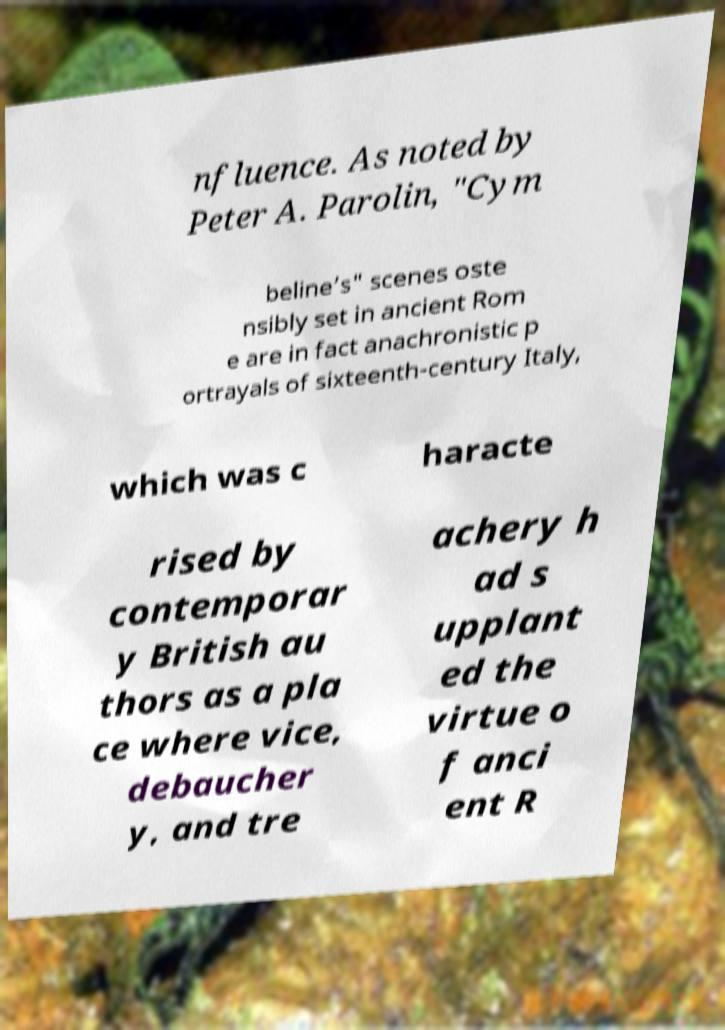Please read and relay the text visible in this image. What does it say? nfluence. As noted by Peter A. Parolin, "Cym beline’s" scenes oste nsibly set in ancient Rom e are in fact anachronistic p ortrayals of sixteenth-century Italy, which was c haracte rised by contemporar y British au thors as a pla ce where vice, debaucher y, and tre achery h ad s upplant ed the virtue o f anci ent R 